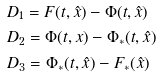Convert formula to latex. <formula><loc_0><loc_0><loc_500><loc_500>& D _ { 1 } = F ( t , \hat { x } ) - \Phi ( t , \hat { x } ) \\ & D _ { 2 } = \Phi ( t , x ) - \Phi _ { * } ( t , \hat { x } ) \\ & D _ { 3 } = \Phi _ { * } ( t , \hat { x } ) - F _ { * } ( \hat { x } )</formula> 